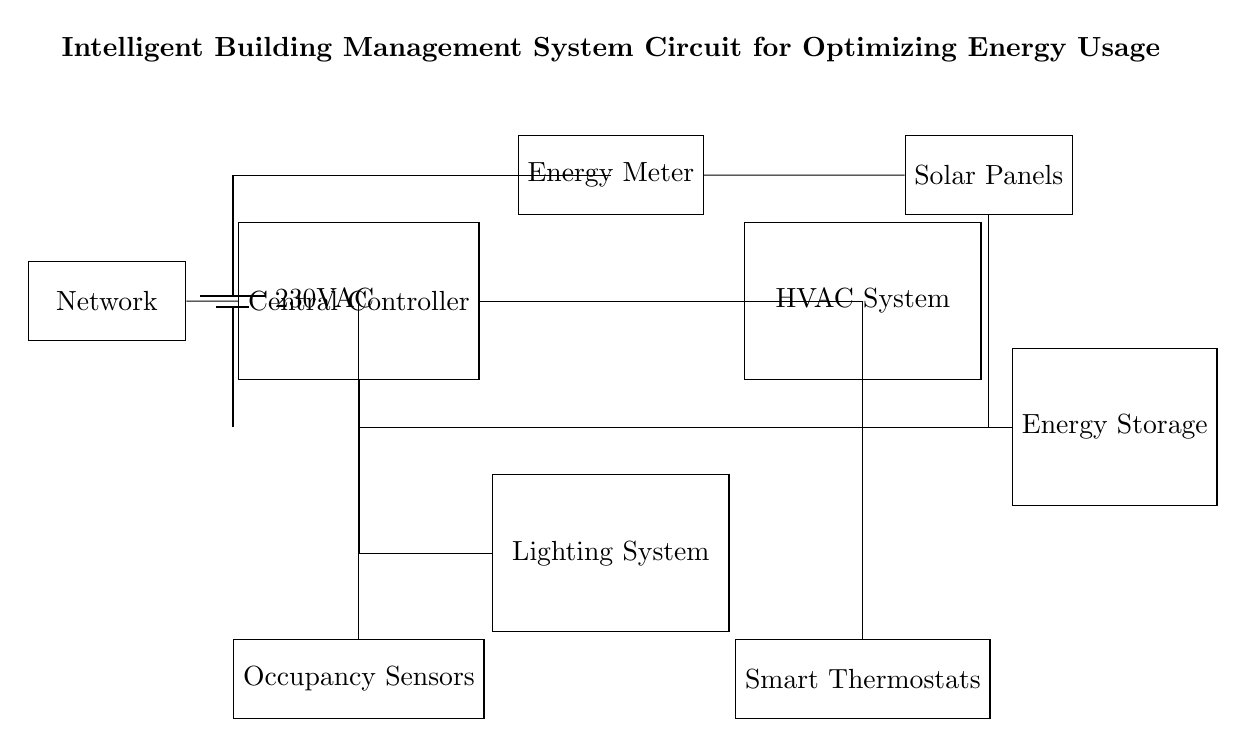what is the main power supply voltage for this circuit? The diagram indicates that the main power supply voltage is marked as 230 volts AC. This voltage is depicted by the battery symbol labeled with this specification.
Answer: 230 volts AC which component controls the HVAC system? The Central Controller is the component responsible for controlling the HVAC system in the circuit, as indicated by the direct connection between the controller and HVAC.
Answer: Central Controller how is the energy meter connected in the circuit? The Energy Meter is connected directly to the Main Power Supply and the Solar Panels, showing that it monitors the energy flowing from these components. This is evidenced by the straight connection lines depicted in the circuit.
Answer: Directly to the Main Power Supply and Solar Panels what is the function of the occupancy sensors in this system? The Occupancy Sensors are connected to the Central Controller, indicating that their function is likely to monitor the presence of occupants and relay this information to the controller for energy optimization decisions.
Answer: Monitor presence how does energy storage interact with solar panels and the central controller? The Energy Storage component receives energy from the Solar Panels via the connection indicated, and it also connects to the Central Controller. This indicates a bidirectional flow where stored energy can be monitored and managed by the controller for efficiency purposes.
Answer: Receives energy from solar panels and connects to Central Controller which system is connected to smart thermostats? The circuit shows that the Smart Thermostats are connected to the HVAC system, implying they are used for managing heating and cooling based on their programming, enhancing energy optimization.
Answer: HVAC system 